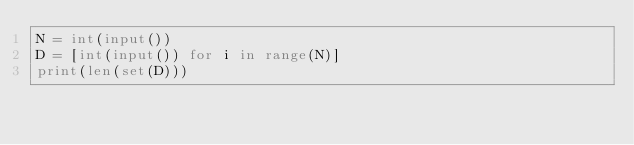Convert code to text. <code><loc_0><loc_0><loc_500><loc_500><_Python_>N = int(input())
D = [int(input()) for i in range(N)]
print(len(set(D)))</code> 